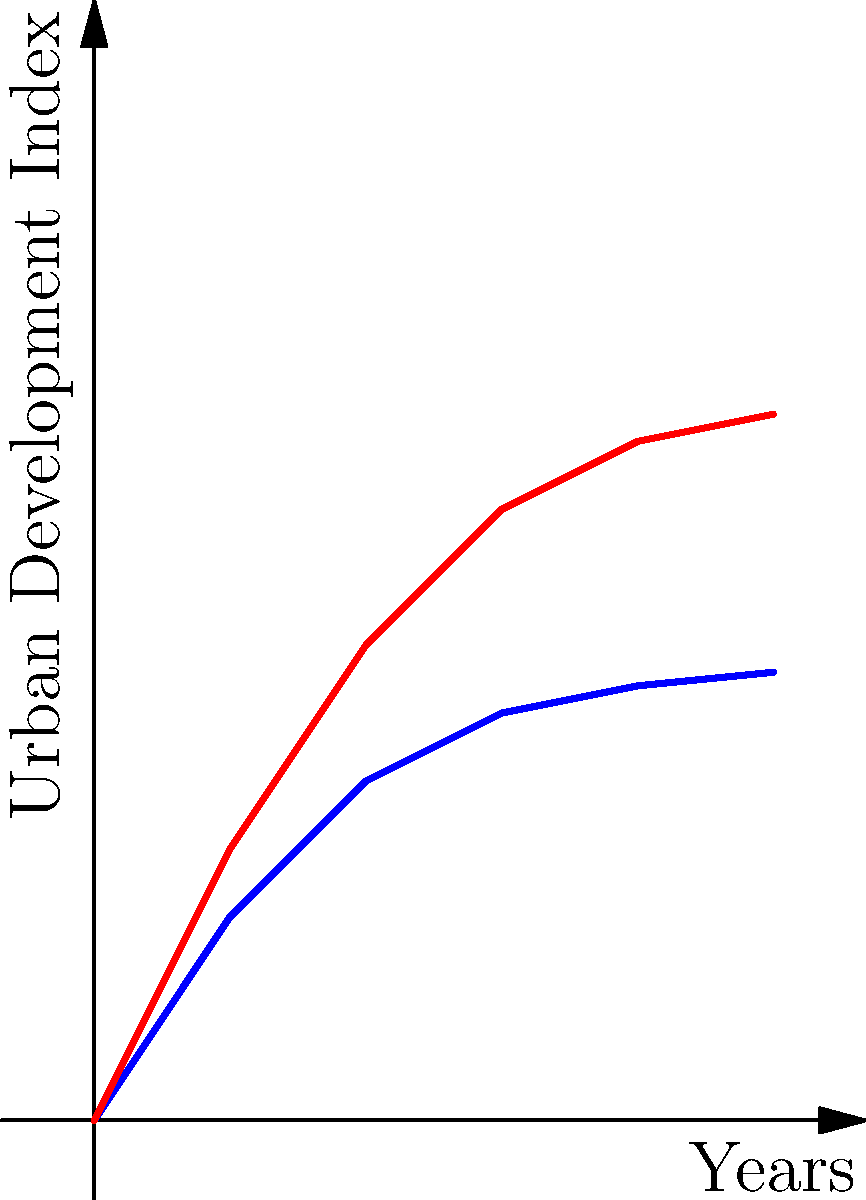Based on the graph showing urban development trends before and after Kennedy's New Frontier policies, what can be inferred about the impact of these policies on urban planning layouts? Provide a quantitative analysis of the change in the Urban Development Index over the 5-year period. To analyze the impact of Kennedy's New Frontier policies on urban planning layouts, we need to compare the slopes of the two lines and calculate the change in the Urban Development Index:

1. Before New Frontier:
   Initial value: 0
   Final value after 5 years: 3.3
   Change: 3.3 - 0 = 3.3

2. After New Frontier:
   Initial value: 0
   Final value after 5 years: 5.2
   Change: 5.2 - 0 = 5.2

3. Calculate the difference in change:
   Difference = After New Frontier change - Before New Frontier change
               = 5.2 - 3.3 = 1.9

4. Calculate the percentage increase:
   Percentage increase = (Difference / Before New Frontier change) * 100
                       = (1.9 / 3.3) * 100 ≈ 57.58%

5. Analyze the slopes:
   The "After New Frontier" line has a steeper slope, indicating a faster rate of urban development.

6. Interpret the results:
   The New Frontier policies led to a significant acceleration in urban development, with a 57.58% increase in the Urban Development Index over the 5-year period compared to the previous trend.
Answer: Kennedy's New Frontier policies accelerated urban development by 57.58% over 5 years. 